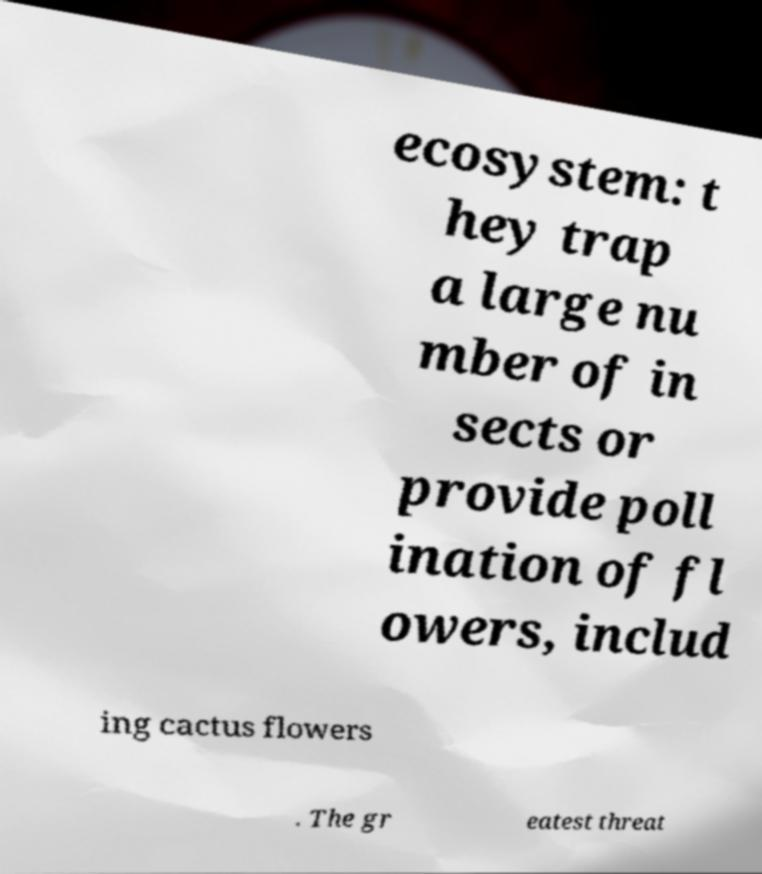Please identify and transcribe the text found in this image. ecosystem: t hey trap a large nu mber of in sects or provide poll ination of fl owers, includ ing cactus flowers . The gr eatest threat 